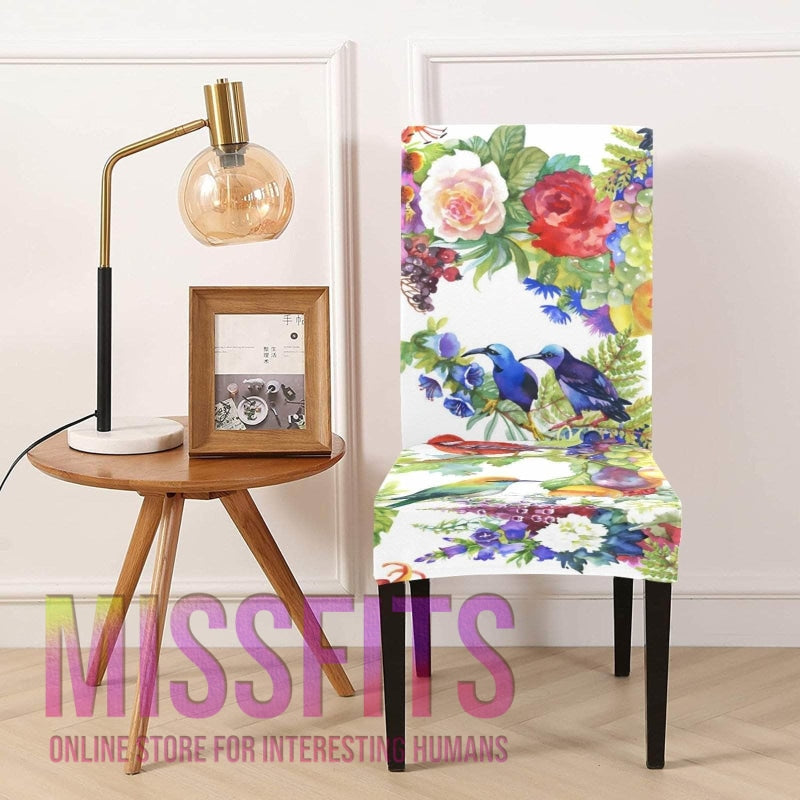Can you describe the setting where this chair is placed? The chair is situated in a well-lit room against a neutral wall, accompanied by a mid-century modern style wooden side table supporting a chic, contemporary table lamp. The table displays a framed picture, possibly a personal memento or artwork. Overall, the setting exudes a personalized and eclectic atmosphere. 